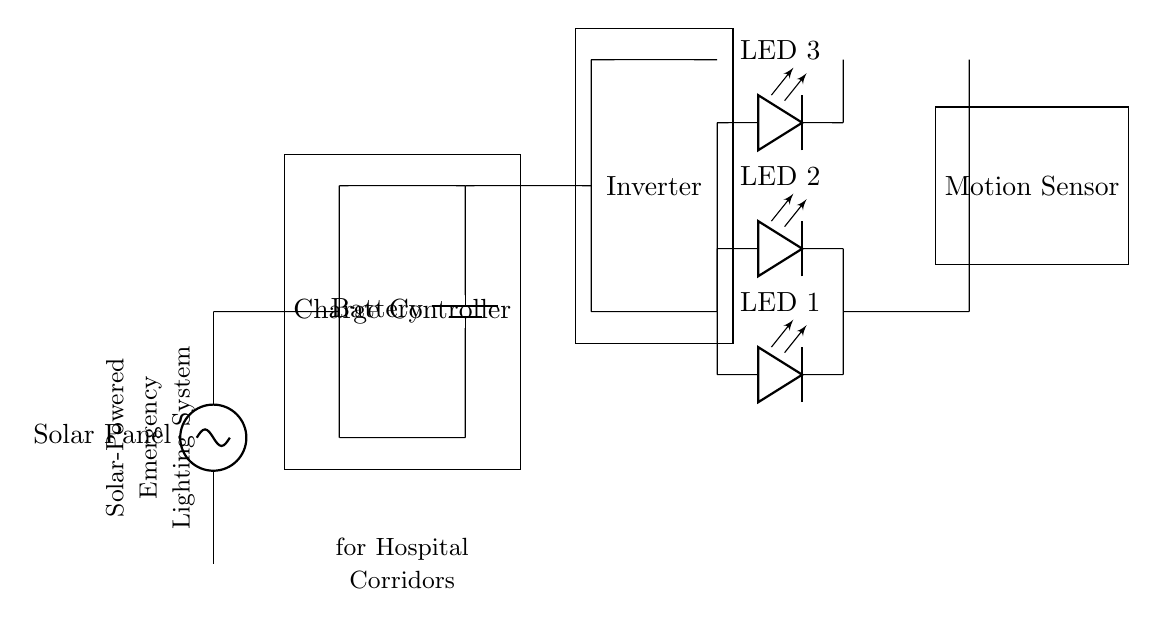What is the source of power in this circuit? The power source is the solar panel, which provides the necessary energy for the system.
Answer: Solar Panel How many LED lights are included in the circuit? There are three LED lights indicated in the circuit diagram, connected in parallel.
Answer: Three What component regulates the charging of the battery? The charge controller is responsible for regulating the power from the solar panel to the battery, preventing overcharging.
Answer: Charge Controller Which component converts DC power to AC power in this circuit? The inverter is used in this circuit to convert the direct current from the battery to alternating current for the LEDs.
Answer: Inverter What type of sensor is utilized to activate the lights? The motion sensor detects movement and activates the LED lights when someone is present in the corridor.
Answer: Motion Sensor What is the primary function of the battery in this circuit? The battery stores energy generated by the solar panel for later use, ensuring the lighting system operates during power outages.
Answer: Store energy What is a common advantage of using LED lights in this system? LED lights are energy-efficient, consuming less power while providing adequate illumination for a low power emergency lighting system.
Answer: Energy-efficient 